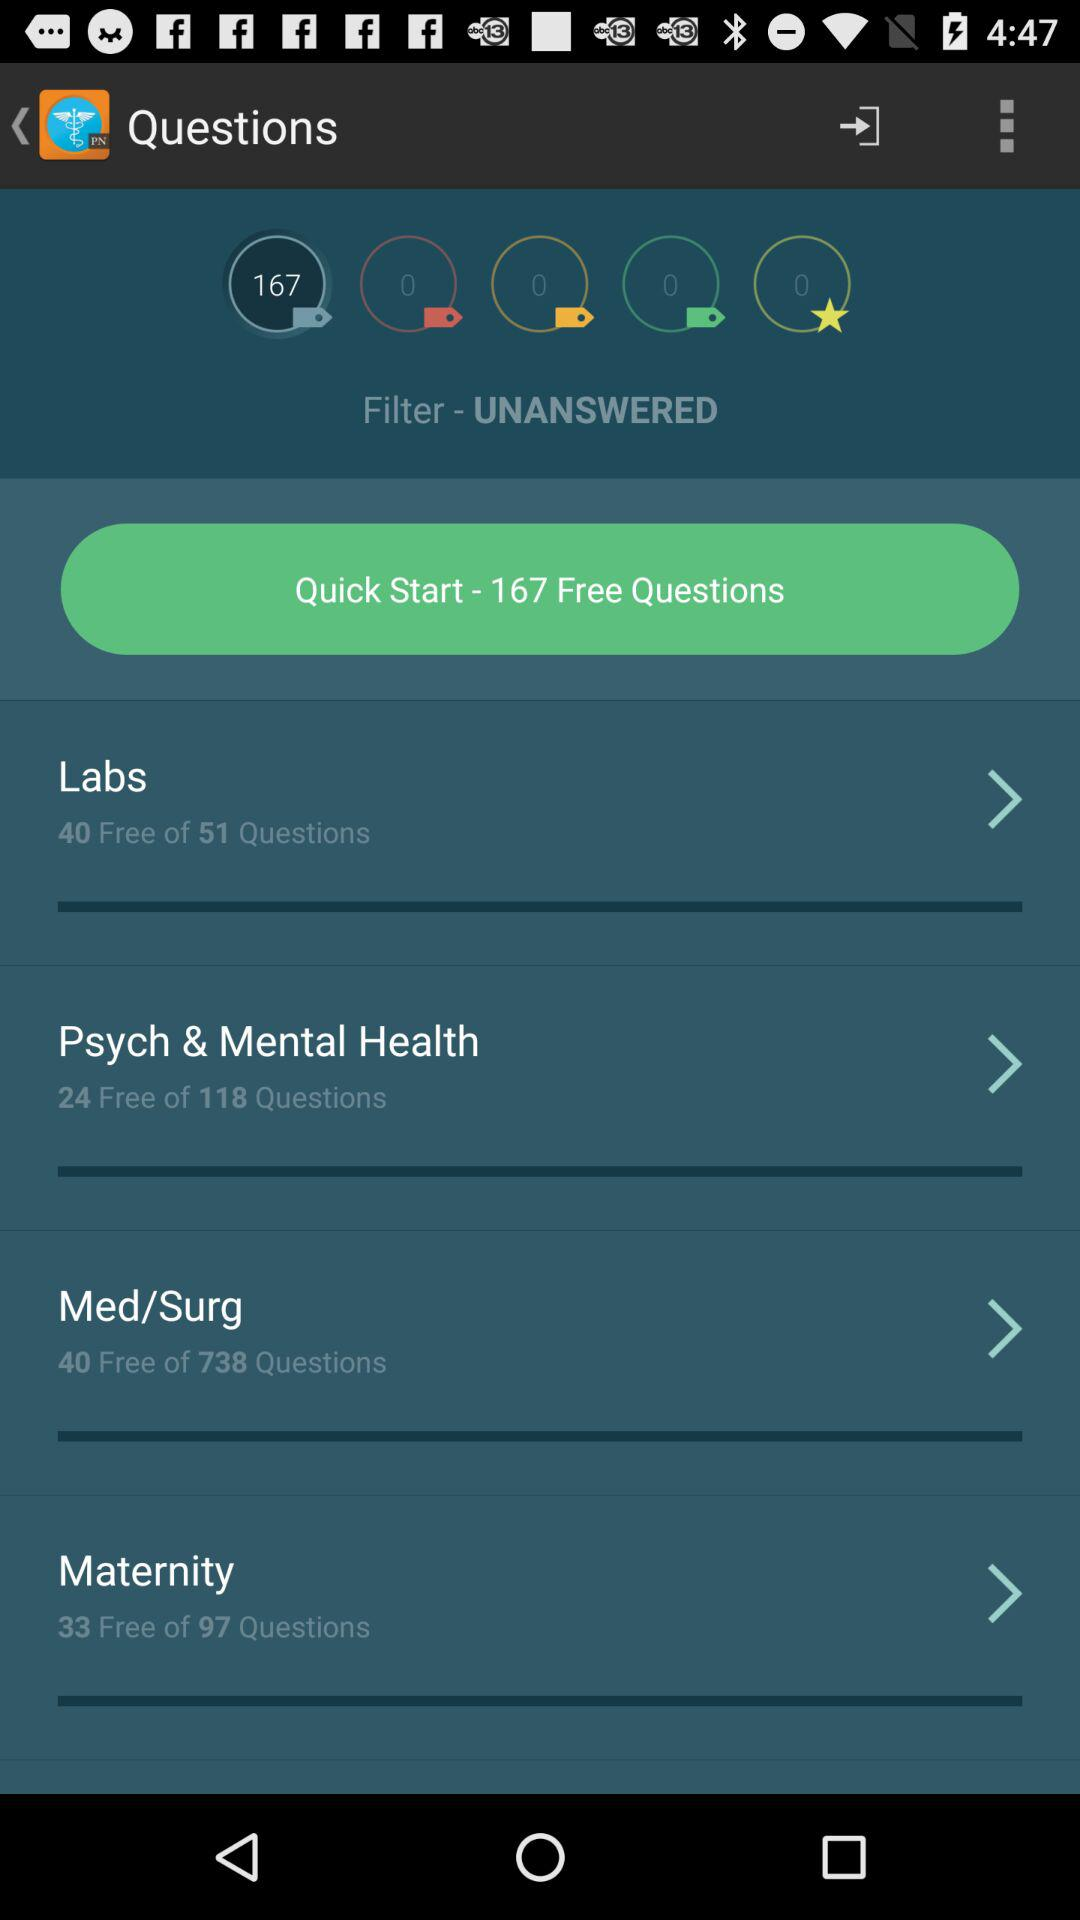How many questions are there in the "Labs" course that are free? There are 40 questions in the "Labs" course that are free. 